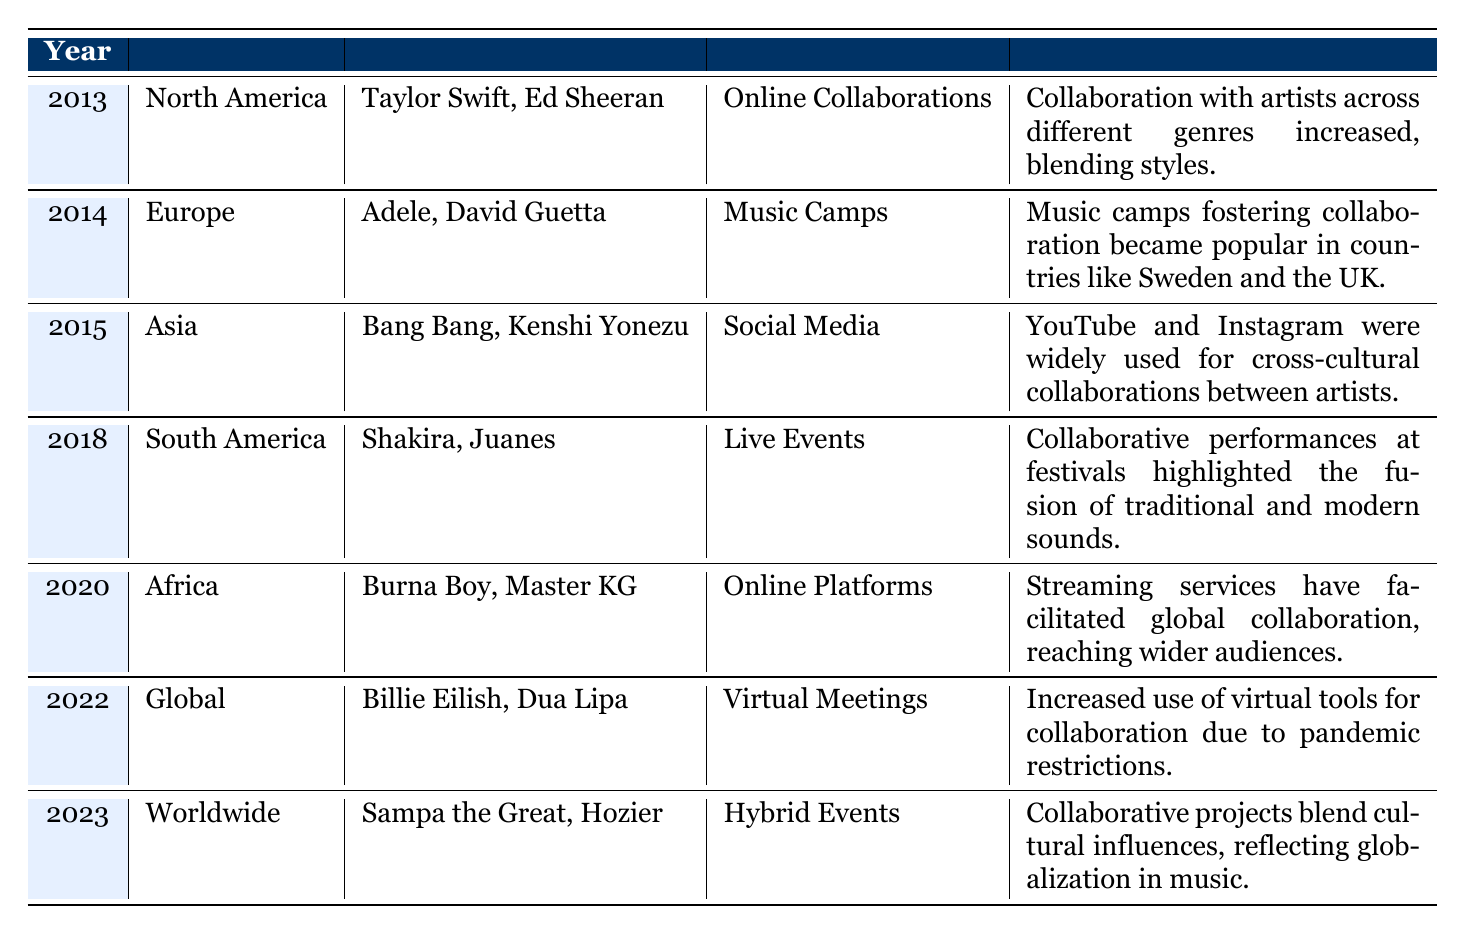What region had notable collaborators Taylor Swift and Ed Sheeran? By looking at the "Notable Collaborators" column and locating Taylor Swift and Ed Sheeran, we can see that they are listed in the row for the year 2013. The corresponding "Region" for that row is "North America."
Answer: North America Which platforms were used for collaborative songwriting in 2020? In the row for the year 2020, the platform mentioned is "Online Platforms." This can be directly found by checking that specific row.
Answer: Online Platforms Did Adele collaborate with artists in North America? Adele is listed as a notable collaborator in the row corresponding to the year 2014, which belongs to the region Europe. Therefore, the answer to whether she collaborated with artists in North America is no.
Answer: No What genres were explored through collaboration in South America in 2018? Referring to the row for the year 2018, the genres listed are "Latin Pop" and "Reggaeton." These genres can be combined by checking that specific row for this region and year.
Answer: Latin Pop, Reggaeton What was the key insight regarding collaborative songwriting in the year 2015? In the row for the year 2015, the key insight describes the use of YouTube and Instagram for cross-cultural collaborations among artists. This information is found in that specific row.
Answer: YouTube and Instagram were widely used for cross-cultural collaborations Which year saw the increased use of virtual tools for collaboration, and what was the region? In the row for the year 2022, the table indicates that there is an increased use of virtual tools for collaboration. The region associated with that year is "Global." Therefore, by checking that specific row, both pieces of information can be obtained together.
Answer: 2022, Global How many different platforms were mentioned across the years listed? We can find the platforms listed in each row: Online Collaborations (2013), Music Camps (2014), Social Media (2015), Live Events (2018), Online Platforms (2020), Virtual Meetings (2022), and Hybrid Events (2023). Counting these unique platforms results in seven distinct platforms.
Answer: 7 Were any African artists mentioned in the table from the data provided? The table includes Burna Boy and Master KG as notable collaborators in the year 2020 for the region "Africa." Thus, the answer is yes since these two artists are from Africa.
Answer: Yes In which year did the insights highlight the fusion of traditional and modern sounds in South America? The row corresponding to the year 2018 discusses collaborative performances at festivals in South America and highlights the fusion of traditional and modern sounds. Thus, this information is directly found in that row.
Answer: 2018 What is the notable trend for collaborative projects observed in 2023? The key insight in the row for the year 2023 states that collaborative projects blend cultural influences and reflect globalization in music. This is found directly in the key insight for that specific row.
Answer: Collaborative projects blend cultural influences, reflecting globalization in music 